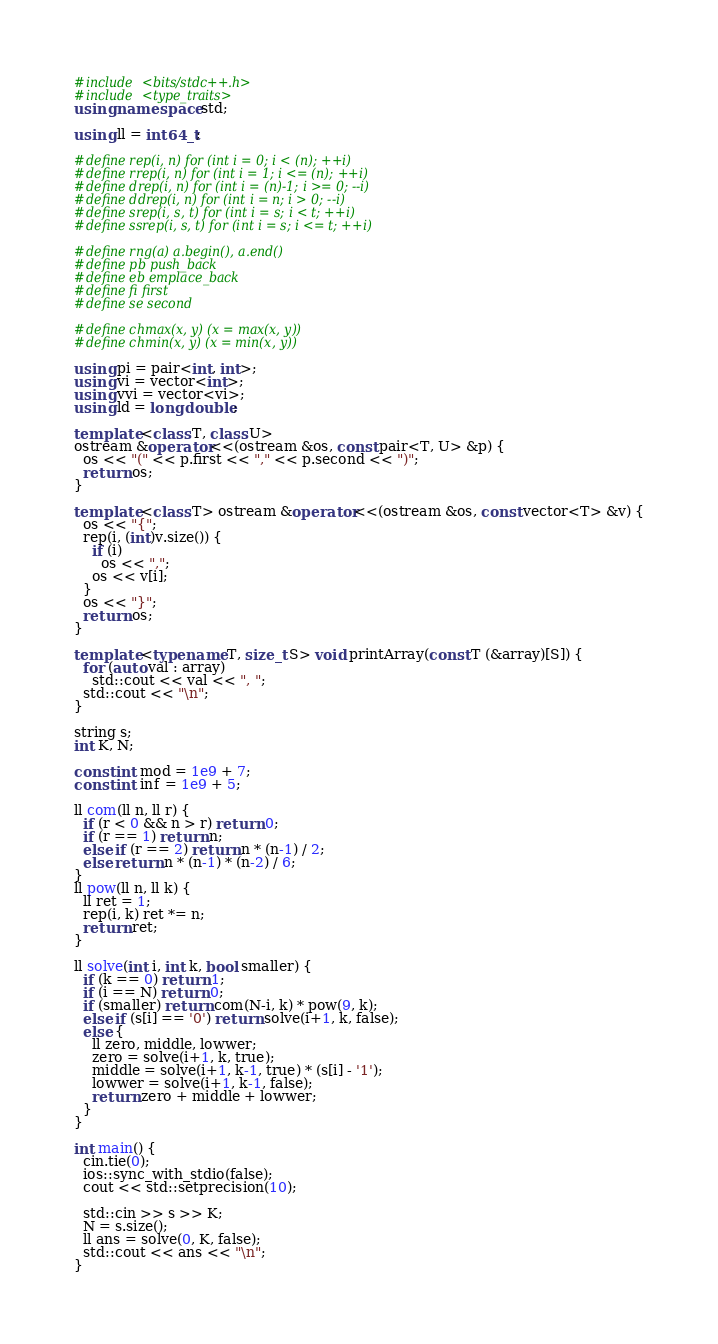Convert code to text. <code><loc_0><loc_0><loc_500><loc_500><_C++_>#include <bits/stdc++.h>
#include <type_traits>
using namespace std;

using ll = int64_t;

#define rep(i, n) for (int i = 0; i < (n); ++i)
#define rrep(i, n) for (int i = 1; i <= (n); ++i)
#define drep(i, n) for (int i = (n)-1; i >= 0; --i)
#define ddrep(i, n) for (int i = n; i > 0; --i)
#define srep(i, s, t) for (int i = s; i < t; ++i)
#define ssrep(i, s, t) for (int i = s; i <= t; ++i)

#define rng(a) a.begin(), a.end()
#define pb push_back
#define eb emplace_back
#define fi first
#define se second

#define chmax(x, y) (x = max(x, y))
#define chmin(x, y) (x = min(x, y))

using pi = pair<int, int>;
using vi = vector<int>;
using vvi = vector<vi>;
using ld = long double;

template <class T, class U>
ostream &operator<<(ostream &os, const pair<T, U> &p) {
  os << "(" << p.first << "," << p.second << ")";
  return os;
}

template <class T> ostream &operator<<(ostream &os, const vector<T> &v) {
  os << "{";
  rep(i, (int)v.size()) {
    if (i)
      os << ",";
    os << v[i];
  }
  os << "}";
  return os;
}

template <typename T, size_t S> void printArray(const T (&array)[S]) {
  for (auto val : array)
    std::cout << val << ", ";
  std::cout << "\n";
}

string s;
int K, N;

const int mod = 1e9 + 7;
const int inf = 1e9 + 5;

ll com(ll n, ll r) {
  if (r < 0 && n > r) return 0;
  if (r == 1) return n;
  else if (r == 2) return n * (n-1) / 2;
  else return n * (n-1) * (n-2) / 6;
}
ll pow(ll n, ll k) {
  ll ret = 1;
  rep(i, k) ret *= n;
  return ret;
}

ll solve(int i, int k, bool smaller) {
  if (k == 0) return 1;
  if (i == N) return 0;
  if (smaller) return com(N-i, k) * pow(9, k);
  else if (s[i] == '0') return solve(i+1, k, false);
  else {
    ll zero, middle, lowwer;
    zero = solve(i+1, k, true);
    middle = solve(i+1, k-1, true) * (s[i] - '1');
    lowwer = solve(i+1, k-1, false);
    return zero + middle + lowwer;
  }
}

int main() {
  cin.tie(0);
  ios::sync_with_stdio(false);
  cout << std::setprecision(10);

  std::cin >> s >> K;
  N = s.size();
  ll ans = solve(0, K, false);
  std::cout << ans << "\n";
}
</code> 